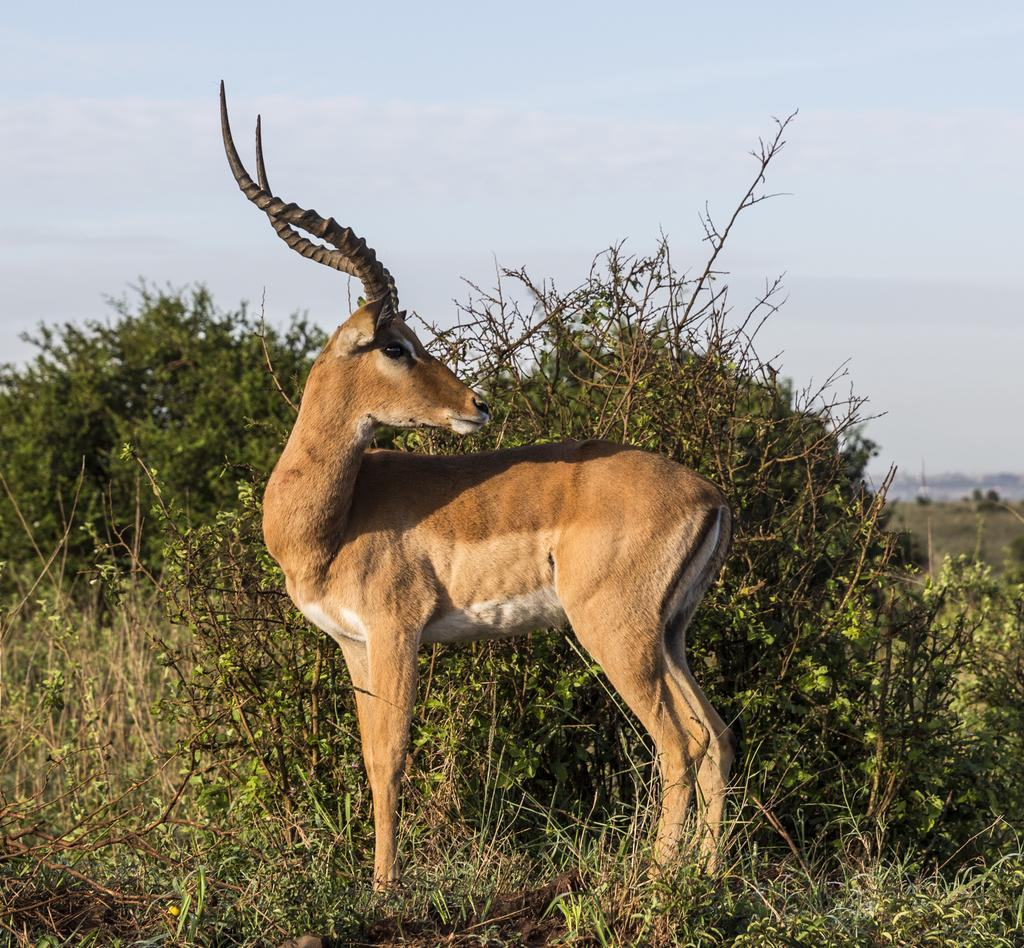What animal can be seen in the image? There is a deer in the image. Where is the deer located? The deer is standing on the land in the image. What type of vegetation is present in the image? There is grass and plants in the image. What is visible at the top of the image? The sky is visible at the top of the image. How many cherries can be seen hanging from the deer's antlers in the image? There are no cherries present in the image, and the deer's antlers are not holding any cherries. 